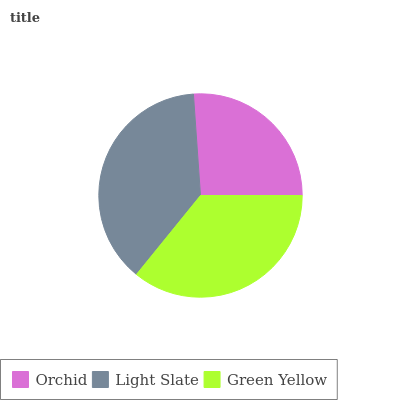Is Orchid the minimum?
Answer yes or no. Yes. Is Light Slate the maximum?
Answer yes or no. Yes. Is Green Yellow the minimum?
Answer yes or no. No. Is Green Yellow the maximum?
Answer yes or no. No. Is Light Slate greater than Green Yellow?
Answer yes or no. Yes. Is Green Yellow less than Light Slate?
Answer yes or no. Yes. Is Green Yellow greater than Light Slate?
Answer yes or no. No. Is Light Slate less than Green Yellow?
Answer yes or no. No. Is Green Yellow the high median?
Answer yes or no. Yes. Is Green Yellow the low median?
Answer yes or no. Yes. Is Orchid the high median?
Answer yes or no. No. Is Orchid the low median?
Answer yes or no. No. 